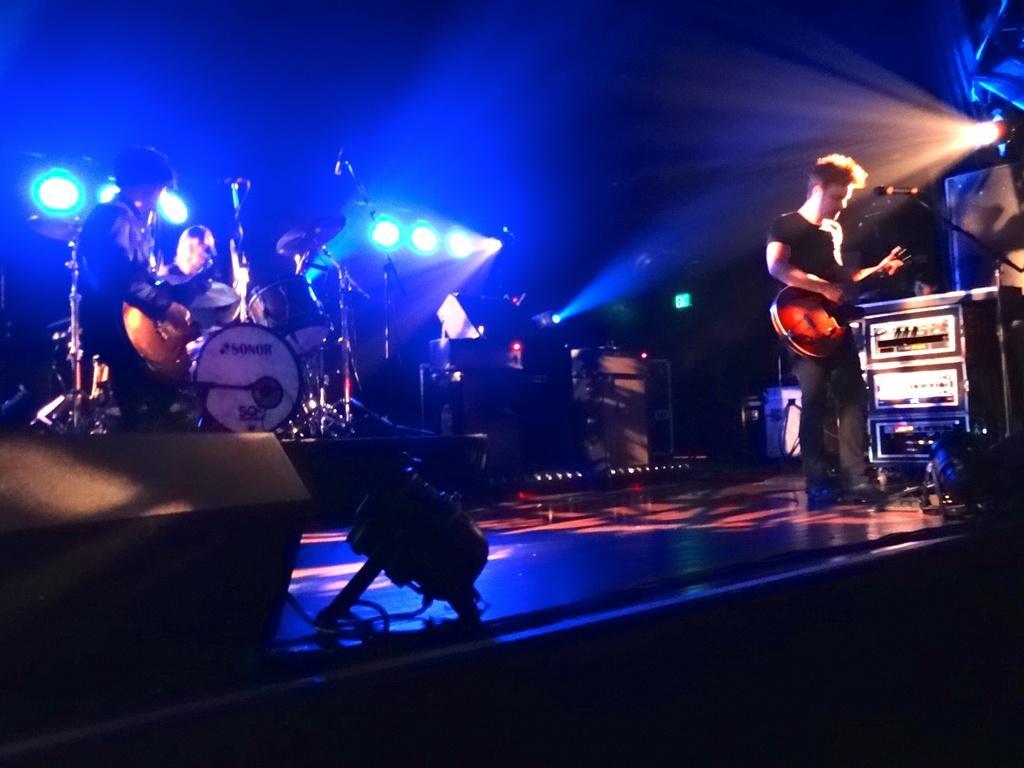Can you describe this image briefly? These are focusing lights. These 2 persons are playing guitar. This man is playing this musical instruments. These are devices. 